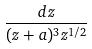Convert formula to latex. <formula><loc_0><loc_0><loc_500><loc_500>\frac { d z } { ( z + a ) ^ { 3 } z ^ { 1 / 2 } }</formula> 